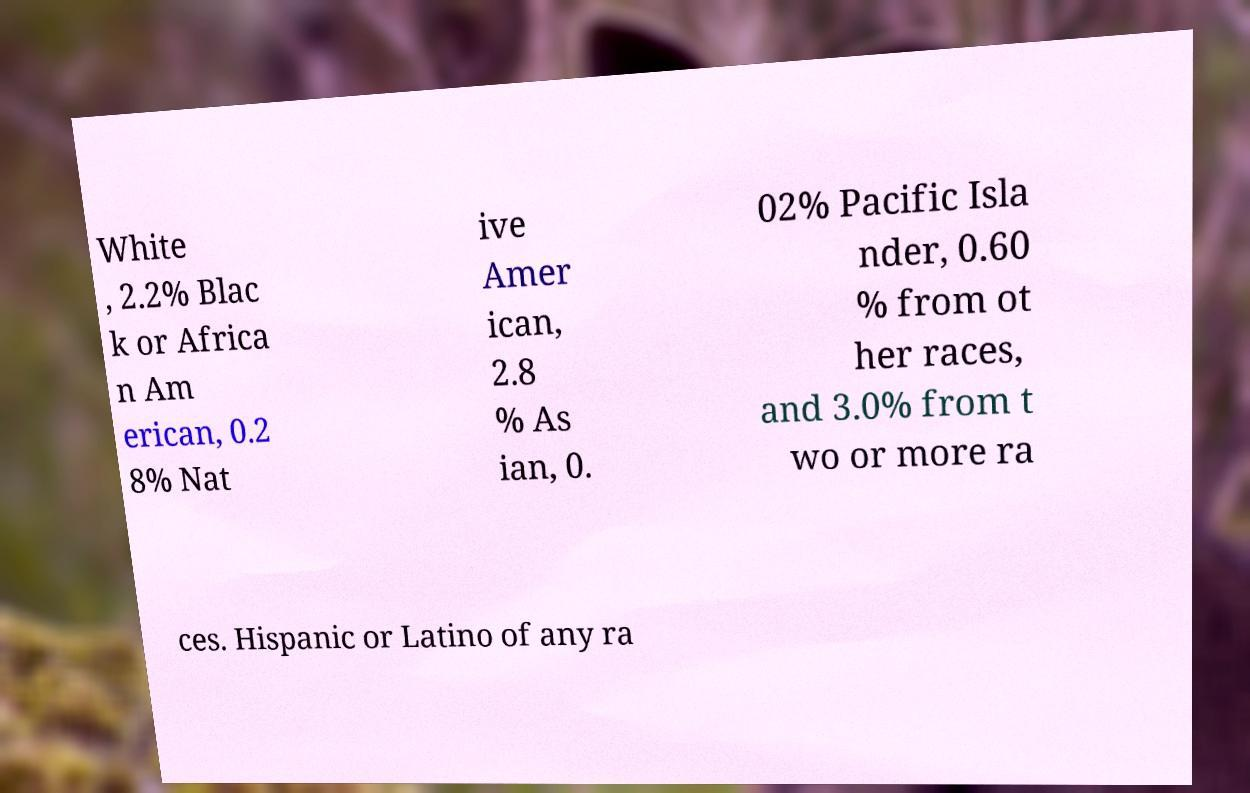Can you read and provide the text displayed in the image?This photo seems to have some interesting text. Can you extract and type it out for me? White , 2.2% Blac k or Africa n Am erican, 0.2 8% Nat ive Amer ican, 2.8 % As ian, 0. 02% Pacific Isla nder, 0.60 % from ot her races, and 3.0% from t wo or more ra ces. Hispanic or Latino of any ra 